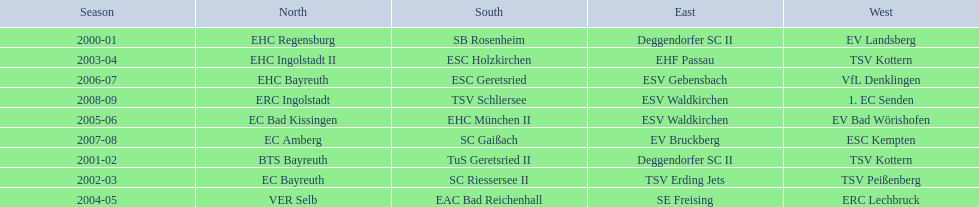Who won the south after esc geretsried did during the 2006-07 season? SC Gaißach. 